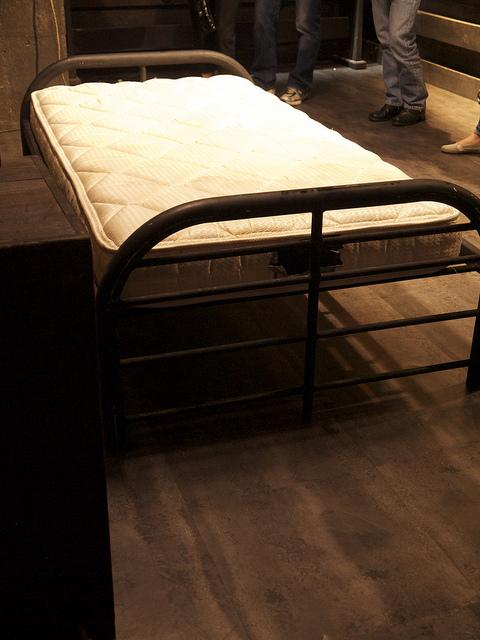What usually happens on the item in the middle of the room? sleep 